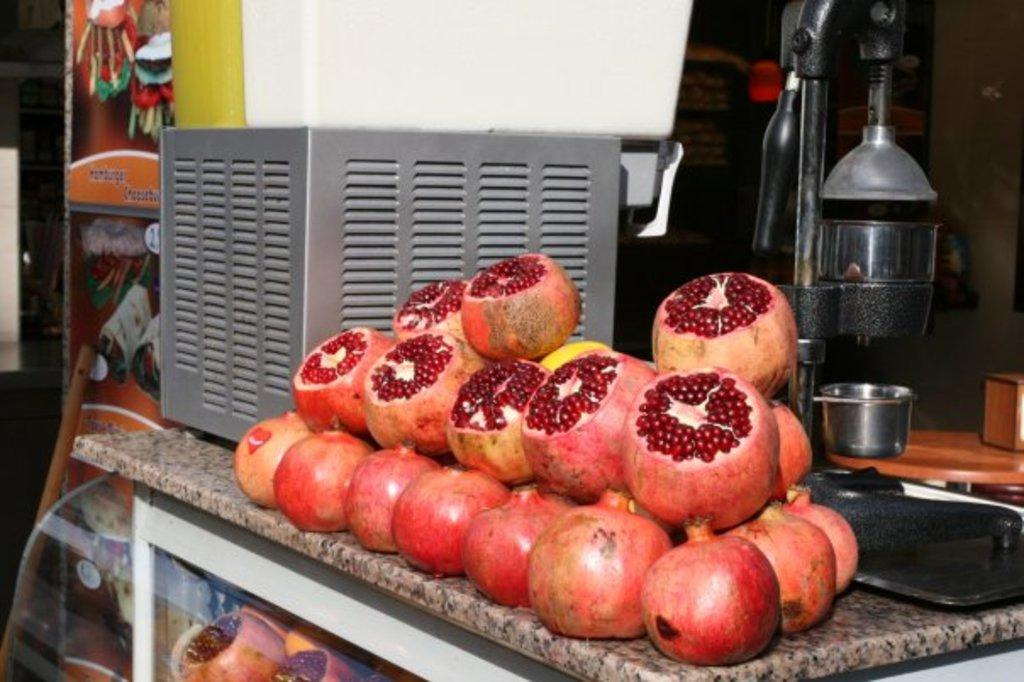What type of furniture is present in the image? There is a cabinet in the image. What is placed on the cabinet? There are pomegranates and a juicer on the cabinet. What type of brass instrument can be seen on the cabinet? There is no brass instrument present on the cabinet; it only contains pomegranates and a juicer. 